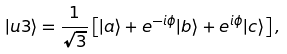<formula> <loc_0><loc_0><loc_500><loc_500>| u 3 \rangle = \frac { 1 } { \sqrt { 3 } } \left [ | a \rangle + e ^ { - i \phi } | b \rangle + e ^ { i \phi } | c \rangle \right ] ,</formula> 